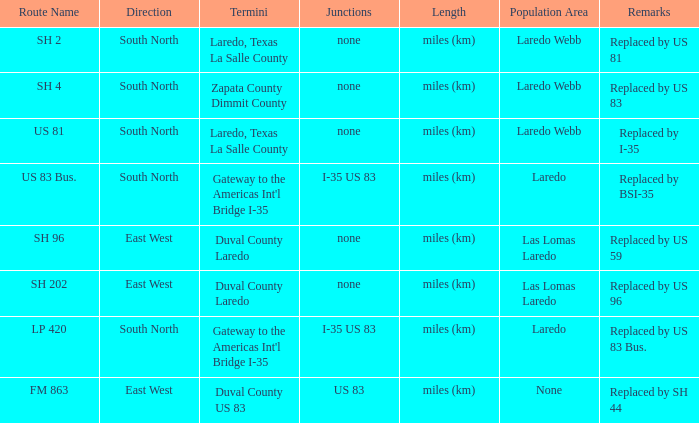For the route with "replaced by us 81" in the remarks section, which length unit is being employed? Miles (km). 